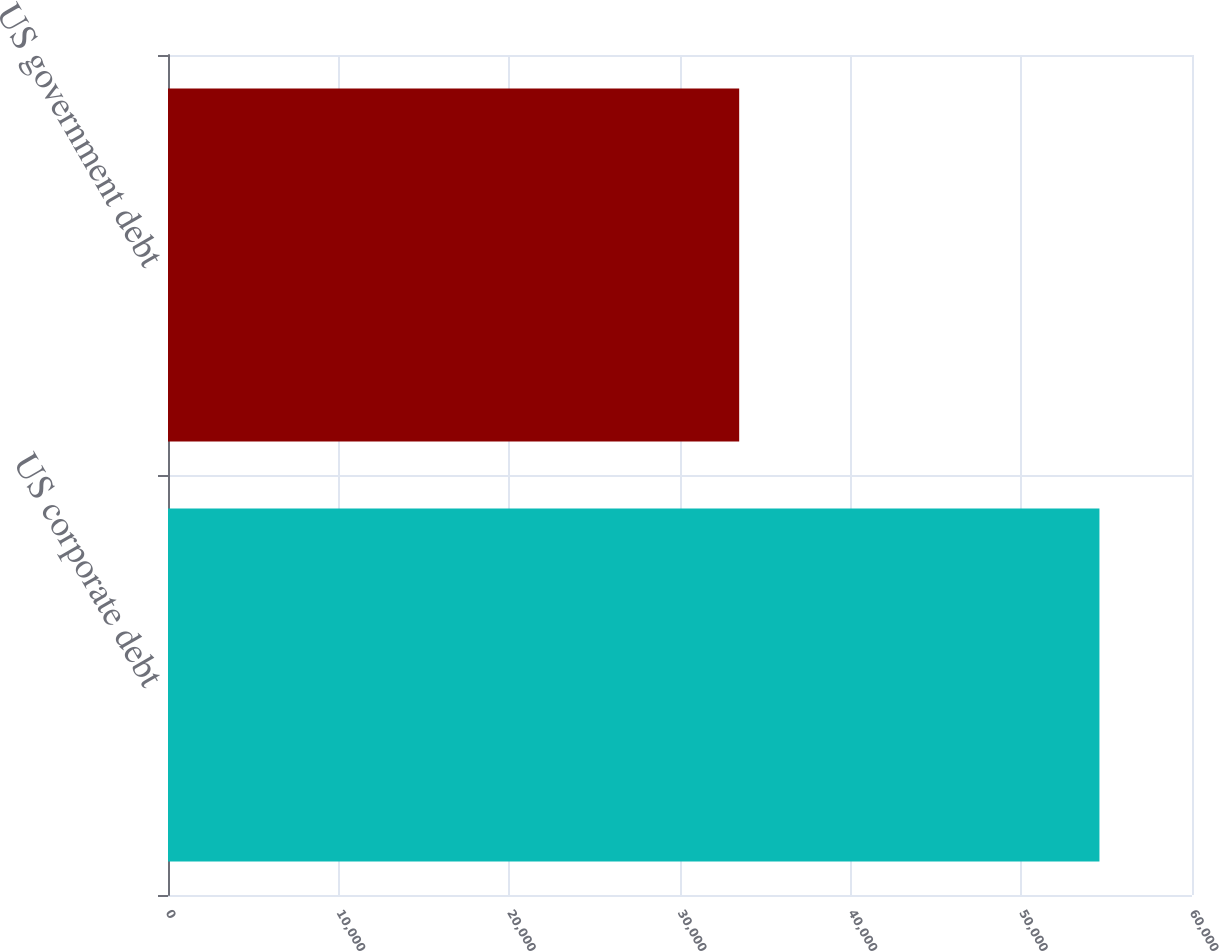Convert chart. <chart><loc_0><loc_0><loc_500><loc_500><bar_chart><fcel>US corporate debt<fcel>US government debt<nl><fcel>54577<fcel>33468<nl></chart> 